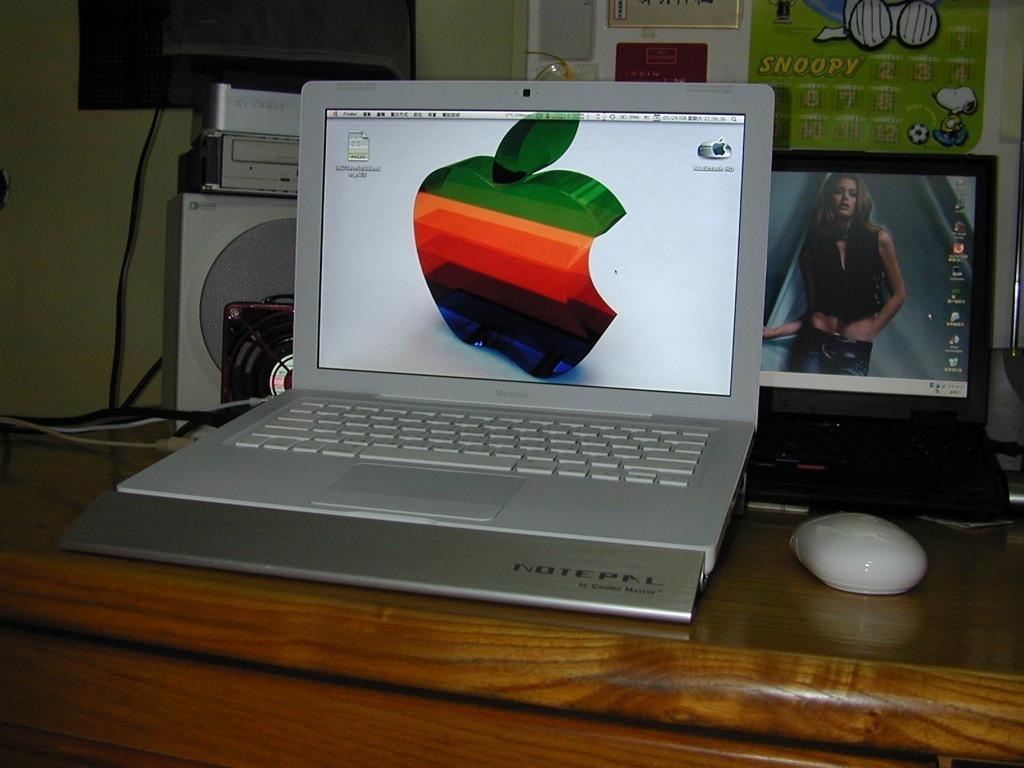Please provide a concise description of this image. In this picture we can see a laptop with an apple wallpaper and another laptop with a girl's desktop wallpaper kept on the table. On the wooden table we can see a mouse, DVD player and other things. 